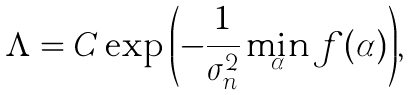Convert formula to latex. <formula><loc_0><loc_0><loc_500><loc_500>\Lambda = C \exp { \left ( - \frac { 1 } { \sigma _ { n } ^ { 2 } } \min _ { \boldsymbol \alpha } f ( \alpha ) \right ) } ,</formula> 